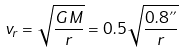Convert formula to latex. <formula><loc_0><loc_0><loc_500><loc_500>v _ { r } = \sqrt { \frac { G M } { r } } = 0 . 5 \sqrt { \frac { 0 . 8 " } { r } }</formula> 